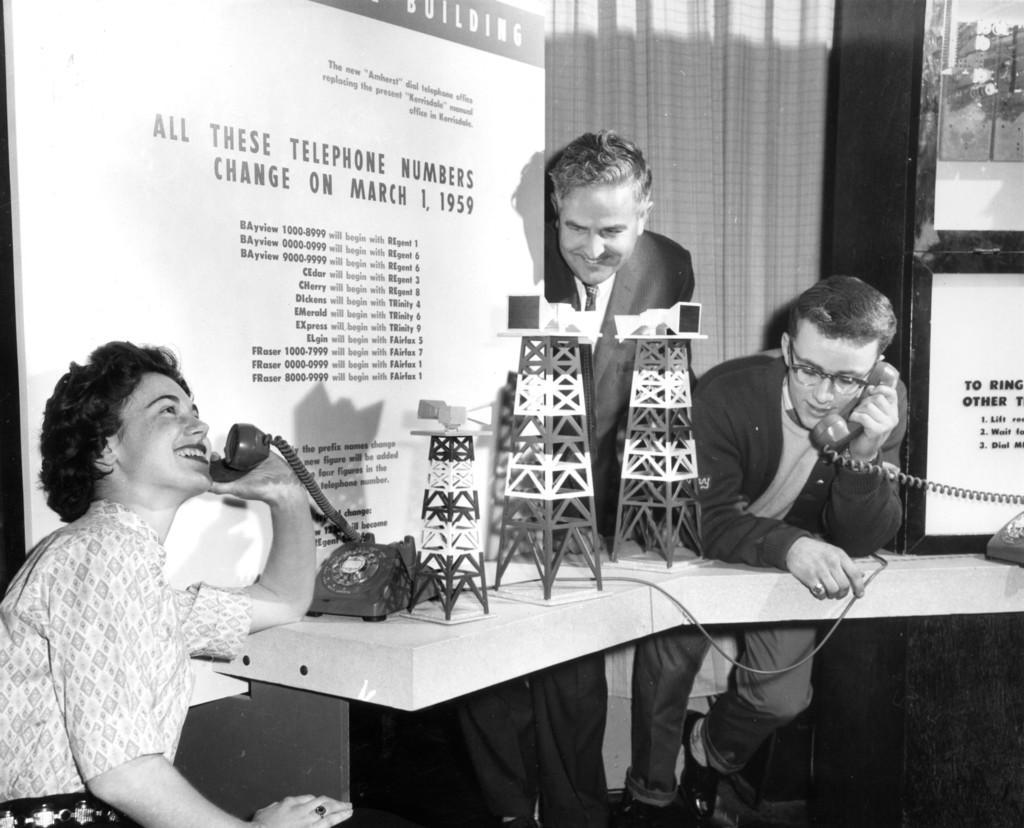In one or two sentences, can you explain what this image depicts? In this image we can see two people talking on the telephone. In the center there is a man standing. At the bottom there is a table and we can see decors and telephones placed on the table. In the background there are boards and a curtain. 